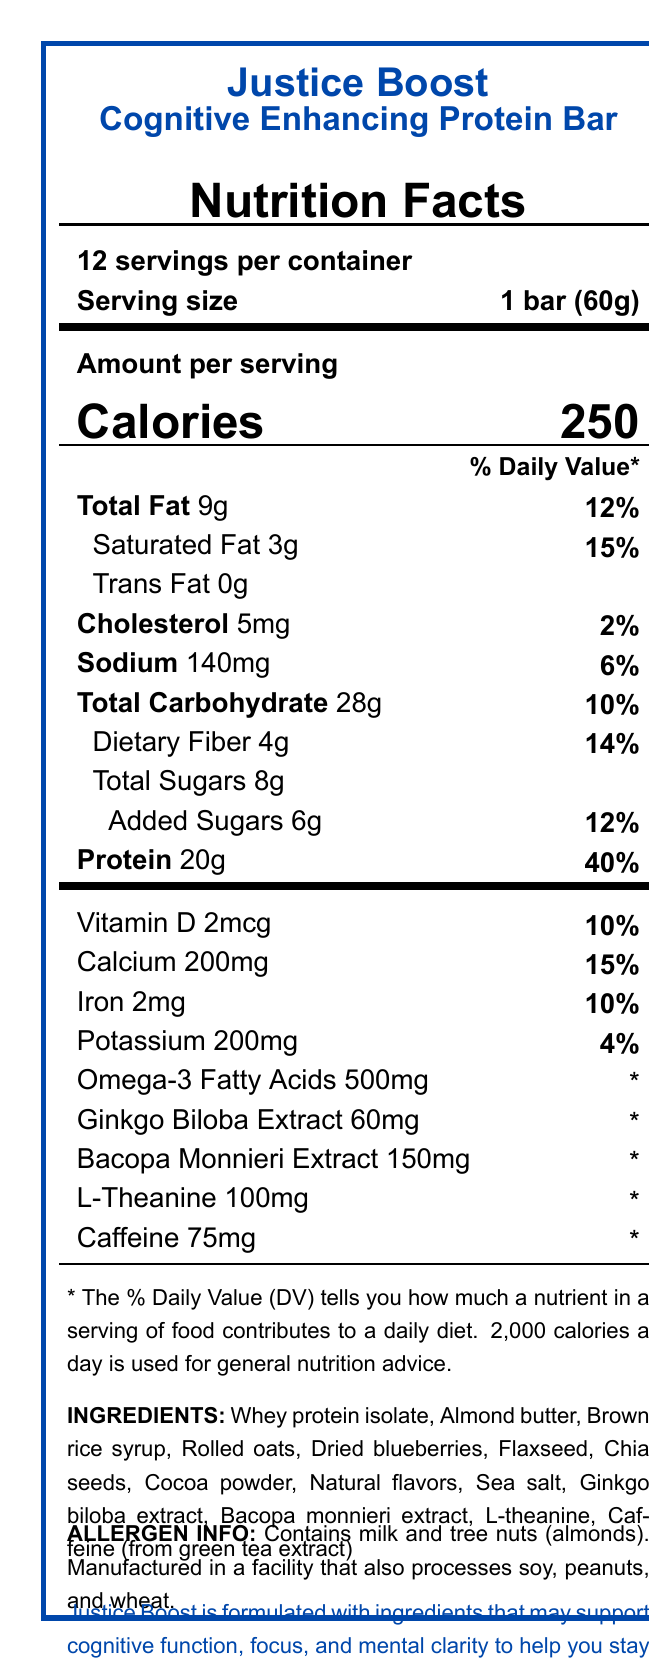what is the serving size of the Justice Boost Cognitive Enhancing Protein Bar? The serving size is specified as "1 bar (60g)" in the nutrition facts section.
Answer: 1 bar (60g) how many servings are in a container? The document states that there are "12 servings per container".
Answer: 12 how many calories are there per serving? The number of calories per serving is listed as "250" under the amount per serving section.
Answer: 250 what is the percentage of daily value for total fat? The percentage of daily value for total fat is shown as "12%" next to the total fat amount of "9g".
Answer: 12% what are the amounts of added sugars and their daily value percentage? The added sugars amount is listed as "6g" with a daily value percentage of "12%".
Answer: 6g, 12% which of the following is an ingredient in the protein bar? A. Soy protein B. Almond butter C. Walnut powder D. Artificial colors The ingredient list includes "Almond butter" while the other options are not listed.
Answer: B how much protein does the bar contain per serving? A. 10g B. 15g C. 20g D. 25g The protein content is "20g" per serving.
Answer: C what is the daily value percentage for calcium? A. 4% B. 10% C. 15% D. 20% The calcium content is "200mg" with a daily value percentage of "15%".
Answer: C is the protein bar free of caffeine? The document shows that the protein bar contains "75mg" of caffeine.
Answer: No summarize the main idea of the Nutrition Facts Label. The summary captures the key details on nutrients, ingredients, cognitive benefits, and allergen information as found in the document.
Answer: The Justice Boost Cognitive Enhancing Protein Bar contains ingredients aiming to support cognitive function. Each bar provides 250 calories with notable amounts of protein, fiber, and various vitamins and minerals. It includes specialized ingredients like Ginkgo Biloba extract, Bacopa Monnieri extract, L-theanine, and caffeine. The bar is made from ethically sourced ingredients and contains milk and tree nuts. does this protein bar provide any information about fair labor practices? The ethical sourcing note mentions that the company is committed to ensuring fair labor practices throughout their supply chain.
Answer: Yes what is the exact percentage of omega-3 fatty acids provided per serving? The document specifies "500mg" of omega-3 fatty acids but notes that the daily value percentage is not established. Therefore, the exact percentage cannot be determined from the provided details.
Answer: Not enough information 